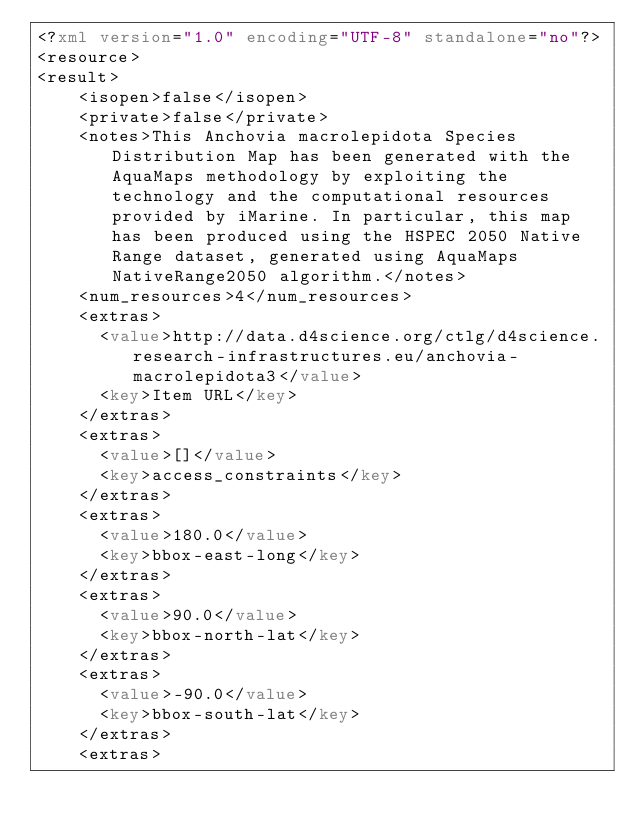<code> <loc_0><loc_0><loc_500><loc_500><_XML_><?xml version="1.0" encoding="UTF-8" standalone="no"?>
<resource>
<result>
    <isopen>false</isopen>
    <private>false</private>
    <notes>This Anchovia macrolepidota Species Distribution Map has been generated with the AquaMaps methodology by exploiting the technology and the computational resources provided by iMarine. In particular, this map has been produced using the HSPEC 2050 Native Range dataset, generated using AquaMaps NativeRange2050 algorithm.</notes>
    <num_resources>4</num_resources>
    <extras>
      <value>http://data.d4science.org/ctlg/d4science.research-infrastructures.eu/anchovia-macrolepidota3</value>
      <key>Item URL</key>
    </extras>
    <extras>
      <value>[]</value>
      <key>access_constraints</key>
    </extras>
    <extras>
      <value>180.0</value>
      <key>bbox-east-long</key>
    </extras>
    <extras>
      <value>90.0</value>
      <key>bbox-north-lat</key>
    </extras>
    <extras>
      <value>-90.0</value>
      <key>bbox-south-lat</key>
    </extras>
    <extras></code> 